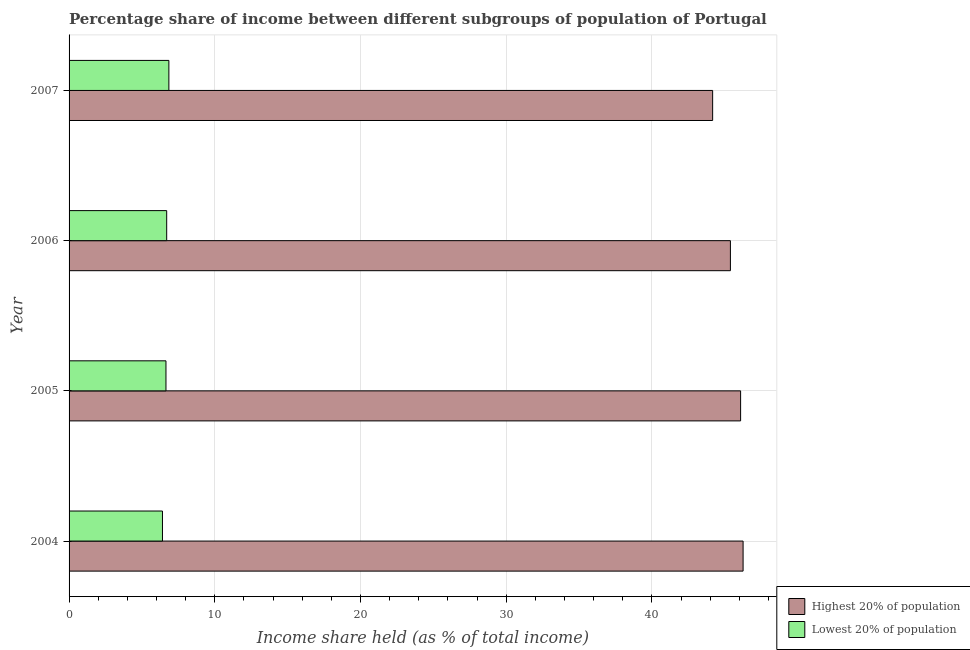How many different coloured bars are there?
Provide a succinct answer. 2. Are the number of bars per tick equal to the number of legend labels?
Offer a very short reply. Yes. Are the number of bars on each tick of the Y-axis equal?
Give a very brief answer. Yes. What is the label of the 4th group of bars from the top?
Your answer should be compact. 2004. What is the income share held by highest 20% of the population in 2007?
Give a very brief answer. 44.17. Across all years, what is the maximum income share held by highest 20% of the population?
Offer a very short reply. 46.26. Across all years, what is the minimum income share held by lowest 20% of the population?
Keep it short and to the point. 6.41. What is the total income share held by lowest 20% of the population in the graph?
Provide a short and direct response. 26.61. What is the difference between the income share held by highest 20% of the population in 2005 and that in 2007?
Make the answer very short. 1.92. What is the difference between the income share held by lowest 20% of the population in 2006 and the income share held by highest 20% of the population in 2004?
Your response must be concise. -39.56. What is the average income share held by highest 20% of the population per year?
Provide a short and direct response. 45.48. In the year 2006, what is the difference between the income share held by highest 20% of the population and income share held by lowest 20% of the population?
Give a very brief answer. 38.69. In how many years, is the income share held by highest 20% of the population greater than 8 %?
Give a very brief answer. 4. What is the ratio of the income share held by highest 20% of the population in 2005 to that in 2007?
Your answer should be compact. 1.04. Is the difference between the income share held by highest 20% of the population in 2004 and 2005 greater than the difference between the income share held by lowest 20% of the population in 2004 and 2005?
Provide a succinct answer. Yes. What is the difference between the highest and the lowest income share held by lowest 20% of the population?
Keep it short and to the point. 0.44. In how many years, is the income share held by highest 20% of the population greater than the average income share held by highest 20% of the population taken over all years?
Provide a succinct answer. 2. Is the sum of the income share held by highest 20% of the population in 2006 and 2007 greater than the maximum income share held by lowest 20% of the population across all years?
Provide a short and direct response. Yes. What does the 2nd bar from the top in 2005 represents?
Make the answer very short. Highest 20% of population. What does the 1st bar from the bottom in 2004 represents?
Ensure brevity in your answer.  Highest 20% of population. How many bars are there?
Provide a short and direct response. 8. Are all the bars in the graph horizontal?
Provide a short and direct response. Yes. Are the values on the major ticks of X-axis written in scientific E-notation?
Make the answer very short. No. How many legend labels are there?
Provide a short and direct response. 2. How are the legend labels stacked?
Ensure brevity in your answer.  Vertical. What is the title of the graph?
Offer a terse response. Percentage share of income between different subgroups of population of Portugal. Does "Non-resident workers" appear as one of the legend labels in the graph?
Provide a short and direct response. No. What is the label or title of the X-axis?
Offer a terse response. Income share held (as % of total income). What is the label or title of the Y-axis?
Offer a very short reply. Year. What is the Income share held (as % of total income) in Highest 20% of population in 2004?
Provide a short and direct response. 46.26. What is the Income share held (as % of total income) in Lowest 20% of population in 2004?
Ensure brevity in your answer.  6.41. What is the Income share held (as % of total income) in Highest 20% of population in 2005?
Make the answer very short. 46.09. What is the Income share held (as % of total income) in Lowest 20% of population in 2005?
Offer a terse response. 6.65. What is the Income share held (as % of total income) in Highest 20% of population in 2006?
Offer a very short reply. 45.39. What is the Income share held (as % of total income) of Highest 20% of population in 2007?
Keep it short and to the point. 44.17. What is the Income share held (as % of total income) of Lowest 20% of population in 2007?
Offer a very short reply. 6.85. Across all years, what is the maximum Income share held (as % of total income) of Highest 20% of population?
Your answer should be compact. 46.26. Across all years, what is the maximum Income share held (as % of total income) in Lowest 20% of population?
Keep it short and to the point. 6.85. Across all years, what is the minimum Income share held (as % of total income) in Highest 20% of population?
Your answer should be compact. 44.17. Across all years, what is the minimum Income share held (as % of total income) in Lowest 20% of population?
Your answer should be compact. 6.41. What is the total Income share held (as % of total income) of Highest 20% of population in the graph?
Make the answer very short. 181.91. What is the total Income share held (as % of total income) of Lowest 20% of population in the graph?
Give a very brief answer. 26.61. What is the difference between the Income share held (as % of total income) in Highest 20% of population in 2004 and that in 2005?
Provide a short and direct response. 0.17. What is the difference between the Income share held (as % of total income) of Lowest 20% of population in 2004 and that in 2005?
Ensure brevity in your answer.  -0.24. What is the difference between the Income share held (as % of total income) in Highest 20% of population in 2004 and that in 2006?
Your response must be concise. 0.87. What is the difference between the Income share held (as % of total income) of Lowest 20% of population in 2004 and that in 2006?
Give a very brief answer. -0.29. What is the difference between the Income share held (as % of total income) of Highest 20% of population in 2004 and that in 2007?
Keep it short and to the point. 2.09. What is the difference between the Income share held (as % of total income) in Lowest 20% of population in 2004 and that in 2007?
Ensure brevity in your answer.  -0.44. What is the difference between the Income share held (as % of total income) of Highest 20% of population in 2005 and that in 2006?
Provide a short and direct response. 0.7. What is the difference between the Income share held (as % of total income) of Lowest 20% of population in 2005 and that in 2006?
Offer a very short reply. -0.05. What is the difference between the Income share held (as % of total income) in Highest 20% of population in 2005 and that in 2007?
Keep it short and to the point. 1.92. What is the difference between the Income share held (as % of total income) of Highest 20% of population in 2006 and that in 2007?
Your answer should be very brief. 1.22. What is the difference between the Income share held (as % of total income) in Highest 20% of population in 2004 and the Income share held (as % of total income) in Lowest 20% of population in 2005?
Give a very brief answer. 39.61. What is the difference between the Income share held (as % of total income) of Highest 20% of population in 2004 and the Income share held (as % of total income) of Lowest 20% of population in 2006?
Offer a very short reply. 39.56. What is the difference between the Income share held (as % of total income) of Highest 20% of population in 2004 and the Income share held (as % of total income) of Lowest 20% of population in 2007?
Provide a short and direct response. 39.41. What is the difference between the Income share held (as % of total income) of Highest 20% of population in 2005 and the Income share held (as % of total income) of Lowest 20% of population in 2006?
Your answer should be compact. 39.39. What is the difference between the Income share held (as % of total income) of Highest 20% of population in 2005 and the Income share held (as % of total income) of Lowest 20% of population in 2007?
Offer a very short reply. 39.24. What is the difference between the Income share held (as % of total income) of Highest 20% of population in 2006 and the Income share held (as % of total income) of Lowest 20% of population in 2007?
Give a very brief answer. 38.54. What is the average Income share held (as % of total income) in Highest 20% of population per year?
Your answer should be very brief. 45.48. What is the average Income share held (as % of total income) of Lowest 20% of population per year?
Your answer should be compact. 6.65. In the year 2004, what is the difference between the Income share held (as % of total income) in Highest 20% of population and Income share held (as % of total income) in Lowest 20% of population?
Offer a terse response. 39.85. In the year 2005, what is the difference between the Income share held (as % of total income) in Highest 20% of population and Income share held (as % of total income) in Lowest 20% of population?
Give a very brief answer. 39.44. In the year 2006, what is the difference between the Income share held (as % of total income) of Highest 20% of population and Income share held (as % of total income) of Lowest 20% of population?
Your answer should be compact. 38.69. In the year 2007, what is the difference between the Income share held (as % of total income) in Highest 20% of population and Income share held (as % of total income) in Lowest 20% of population?
Make the answer very short. 37.32. What is the ratio of the Income share held (as % of total income) in Lowest 20% of population in 2004 to that in 2005?
Your response must be concise. 0.96. What is the ratio of the Income share held (as % of total income) in Highest 20% of population in 2004 to that in 2006?
Offer a terse response. 1.02. What is the ratio of the Income share held (as % of total income) in Lowest 20% of population in 2004 to that in 2006?
Your response must be concise. 0.96. What is the ratio of the Income share held (as % of total income) of Highest 20% of population in 2004 to that in 2007?
Your response must be concise. 1.05. What is the ratio of the Income share held (as % of total income) of Lowest 20% of population in 2004 to that in 2007?
Your answer should be compact. 0.94. What is the ratio of the Income share held (as % of total income) of Highest 20% of population in 2005 to that in 2006?
Give a very brief answer. 1.02. What is the ratio of the Income share held (as % of total income) in Lowest 20% of population in 2005 to that in 2006?
Ensure brevity in your answer.  0.99. What is the ratio of the Income share held (as % of total income) in Highest 20% of population in 2005 to that in 2007?
Your response must be concise. 1.04. What is the ratio of the Income share held (as % of total income) of Lowest 20% of population in 2005 to that in 2007?
Ensure brevity in your answer.  0.97. What is the ratio of the Income share held (as % of total income) of Highest 20% of population in 2006 to that in 2007?
Your response must be concise. 1.03. What is the ratio of the Income share held (as % of total income) of Lowest 20% of population in 2006 to that in 2007?
Ensure brevity in your answer.  0.98. What is the difference between the highest and the second highest Income share held (as % of total income) of Highest 20% of population?
Offer a very short reply. 0.17. What is the difference between the highest and the lowest Income share held (as % of total income) of Highest 20% of population?
Provide a short and direct response. 2.09. What is the difference between the highest and the lowest Income share held (as % of total income) in Lowest 20% of population?
Make the answer very short. 0.44. 